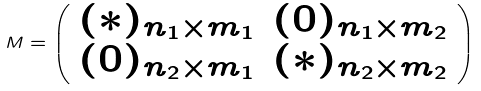Convert formula to latex. <formula><loc_0><loc_0><loc_500><loc_500>M = \left ( \begin{array} { c c } ( * ) _ { n _ { 1 } \times m _ { 1 } } & ( 0 ) _ { n _ { 1 } \times m _ { 2 } } \\ ( 0 ) _ { n _ { 2 } \times m _ { 1 } } & ( * ) _ { n _ { 2 } \times m _ { 2 } } \end{array} \right )</formula> 